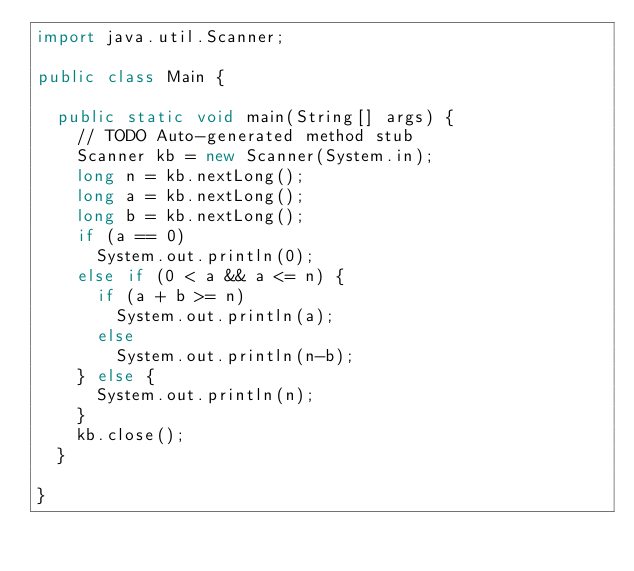Convert code to text. <code><loc_0><loc_0><loc_500><loc_500><_Java_>import java.util.Scanner;

public class Main {

	public static void main(String[] args) {
		// TODO Auto-generated method stub
		Scanner kb = new Scanner(System.in);
		long n = kb.nextLong();
		long a = kb.nextLong();
		long b = kb.nextLong();
		if (a == 0)
			System.out.println(0);
		else if (0 < a && a <= n) {
			if (a + b >= n)
				System.out.println(a);
			else
				System.out.println(n-b);
		} else {
			System.out.println(n);
		}
		kb.close();
	}

}
</code> 